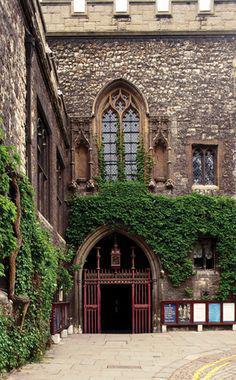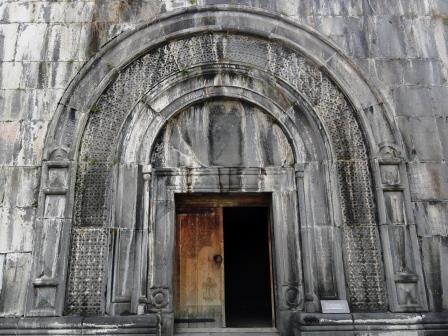The first image is the image on the left, the second image is the image on the right. Examine the images to the left and right. Is the description "In one image, an ornate arched entry with columns and a colored painting under the arch is set in an outside stone wall of a building." accurate? Answer yes or no. No. The first image is the image on the left, the second image is the image on the right. Analyze the images presented: Is the assertion "Multiple people stand in front of an arch in one image." valid? Answer yes or no. No. 